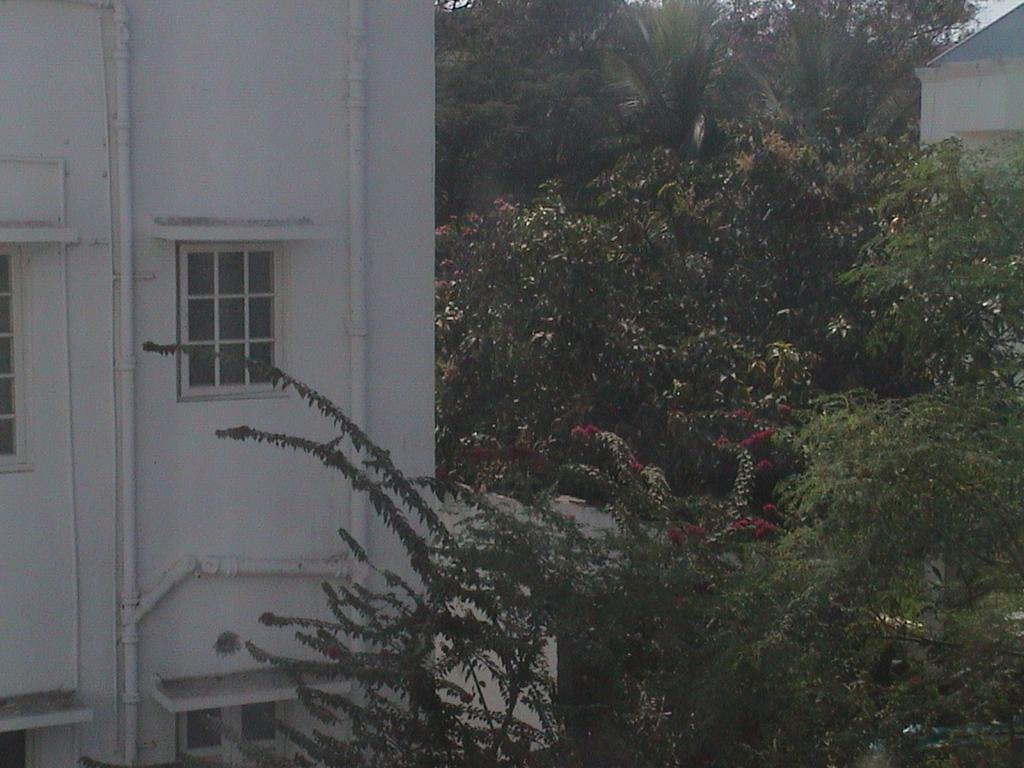What type of living organisms can be seen in the image? Plants and trees are visible in the image. What type of structure is present in the image? There is a building with windows in the image. What other natural elements can be seen in the image? Trees are present in the image. What type of stamp can be seen on the glove in the image? There is no glove or stamp present in the image. How does the wealth of the people in the image compare to that of their neighbors? There is no information about wealth or neighbors in the image. 